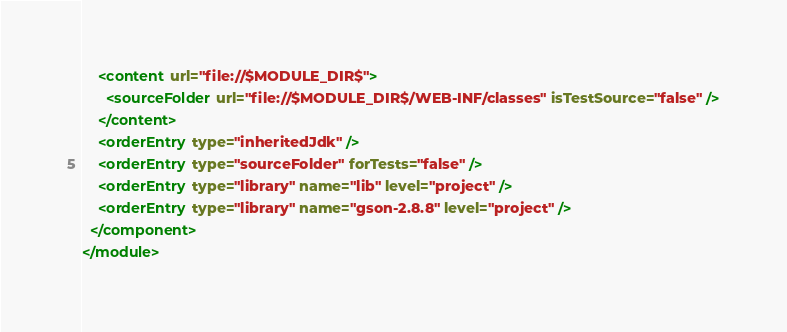<code> <loc_0><loc_0><loc_500><loc_500><_XML_>    <content url="file://$MODULE_DIR$">
      <sourceFolder url="file://$MODULE_DIR$/WEB-INF/classes" isTestSource="false" />
    </content>
    <orderEntry type="inheritedJdk" />
    <orderEntry type="sourceFolder" forTests="false" />
    <orderEntry type="library" name="lib" level="project" />
    <orderEntry type="library" name="gson-2.8.8" level="project" />
  </component>
</module></code> 